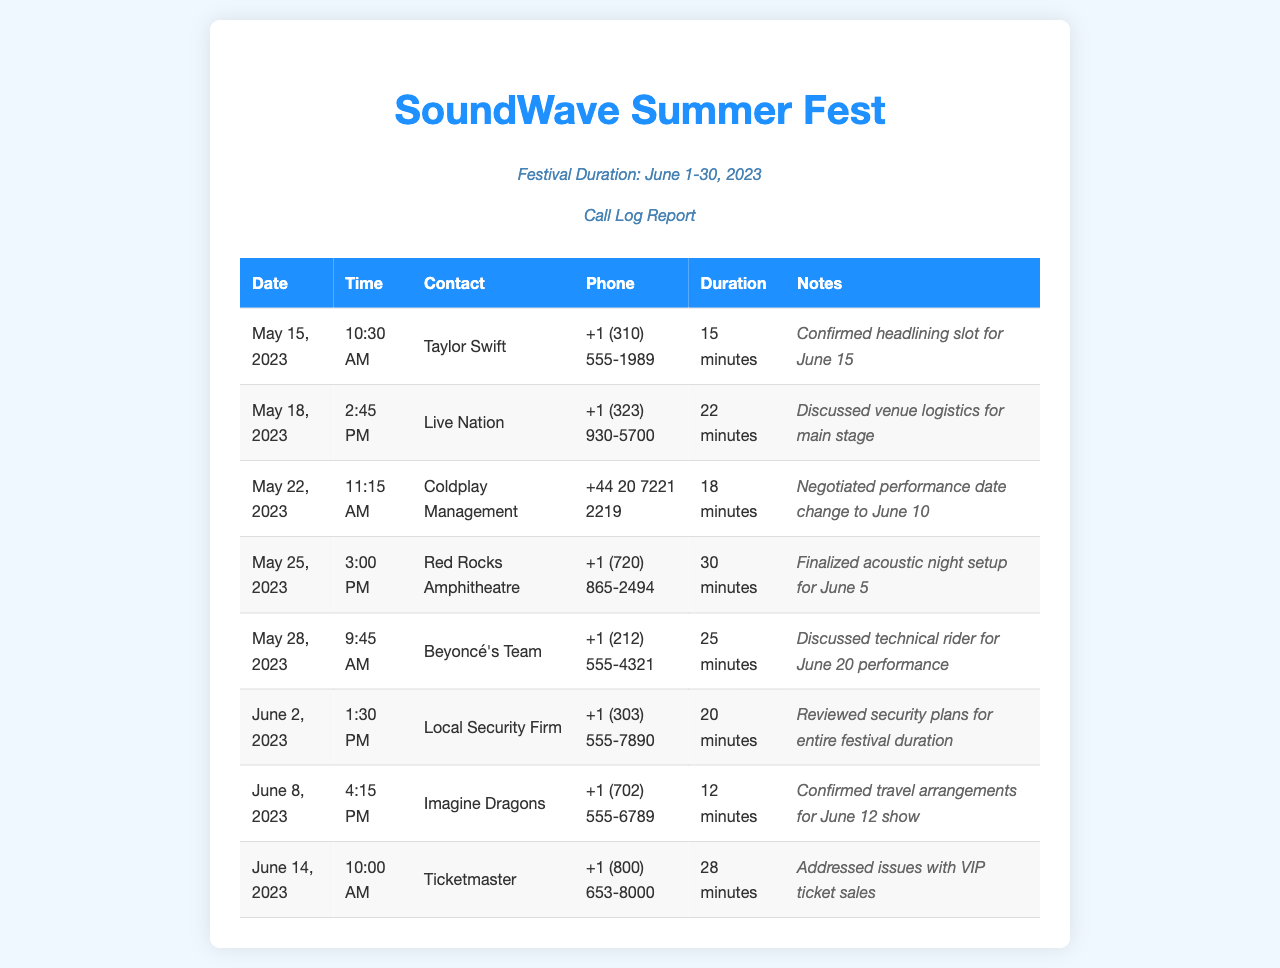What is the date of the call with Taylor Swift? The call with Taylor Swift took place on May 15, 2023.
Answer: May 15, 2023 How long was the call with Live Nation? The duration of the call with Live Nation was noted as 22 minutes.
Answer: 22 minutes What is the phone number for Coldplay Management? The phone number listed for Coldplay Management is +44 20 7221 2219.
Answer: +44 20 7221 2219 What unique logistical aspect was discussed on May 18? The discussion on May 18 focused on venue logistics for the main stage.
Answer: venue logistics for main stage Who confirmed travel arrangements on June 8? The call on June 8 confirmed travel arrangements with Imagine Dragons.
Answer: Imagine Dragons What date is Beyoncé's performance scheduled? Beyoncé’s performance is scheduled for June 20, as stated in the notes.
Answer: June 20 How many minutes was the call with the local security firm? The call with the local security firm lasted 20 minutes.
Answer: 20 minutes What issue was addressed in the call with Ticketmaster? The call with Ticketmaster addressed issues regarding VIP ticket sales.
Answer: VIP ticket sales issues How many calls are recorded before June 1? There are five calls recorded before June 1.
Answer: Five 